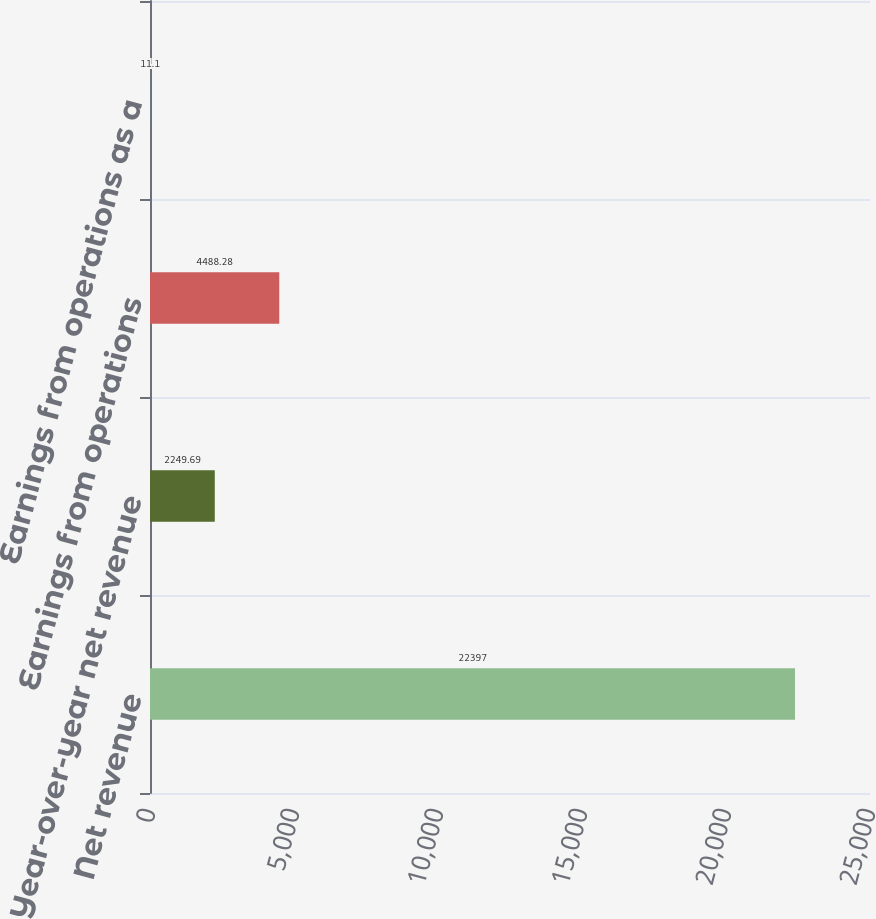<chart> <loc_0><loc_0><loc_500><loc_500><bar_chart><fcel>Net revenue<fcel>Year-over-year net revenue<fcel>Earnings from operations<fcel>Earnings from operations as a<nl><fcel>22397<fcel>2249.69<fcel>4488.28<fcel>11.1<nl></chart> 